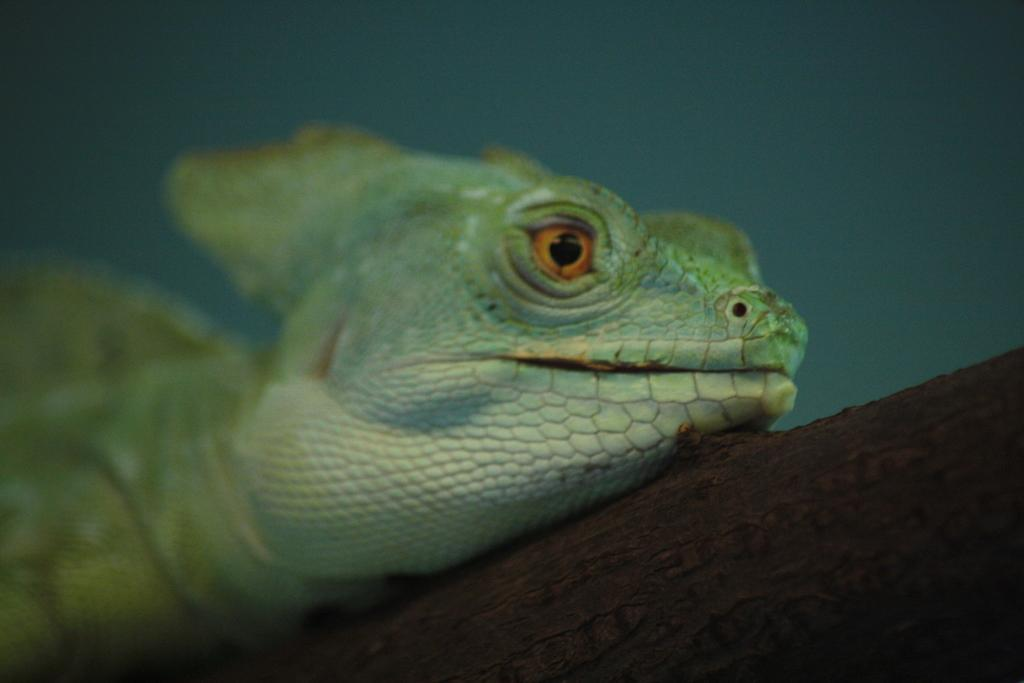What type of animal is in the image? There is a lizard in the image. Where is the lizard located in the image? The lizard is on an object. Can you describe the color of the object? The object is brown in color. What type of holiday is being celebrated in the image? There is no indication of a holiday being celebrated in the image, as it features a lizard on a brown object. What kind of toy is the lizard playing with in the image? There is no toy present in the image, and the lizard is not shown playing with anything. 